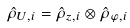<formula> <loc_0><loc_0><loc_500><loc_500>\hat { \rho } _ { U , i } = \hat { \rho } _ { z , i } \otimes \hat { \rho } _ { \varphi , i }</formula> 